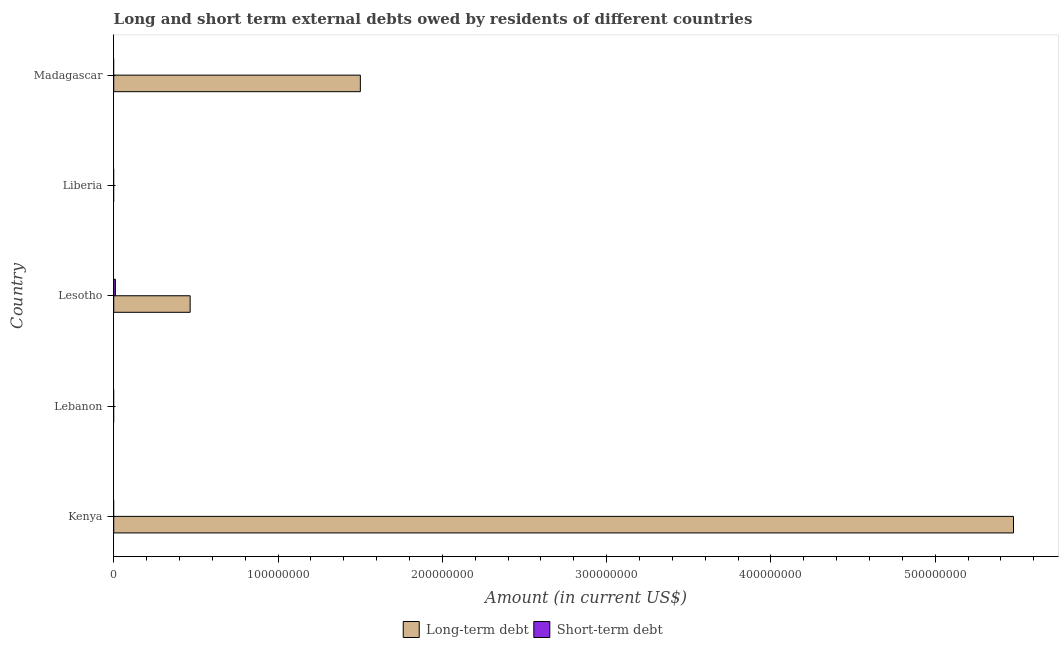How many different coloured bars are there?
Your answer should be compact. 2. Are the number of bars per tick equal to the number of legend labels?
Keep it short and to the point. No. What is the label of the 4th group of bars from the top?
Your answer should be compact. Lebanon. In how many cases, is the number of bars for a given country not equal to the number of legend labels?
Make the answer very short. 4. What is the long-term debts owed by residents in Liberia?
Ensure brevity in your answer.  0. Across all countries, what is the maximum long-term debts owed by residents?
Provide a succinct answer. 5.48e+08. Across all countries, what is the minimum short-term debts owed by residents?
Your response must be concise. 0. In which country was the long-term debts owed by residents maximum?
Provide a succinct answer. Kenya. What is the total long-term debts owed by residents in the graph?
Provide a short and direct response. 7.44e+08. What is the difference between the long-term debts owed by residents in Kenya and that in Lesotho?
Provide a short and direct response. 5.01e+08. What is the difference between the short-term debts owed by residents in Kenya and the long-term debts owed by residents in Madagascar?
Offer a very short reply. -1.50e+08. What is the average short-term debts owed by residents per country?
Your response must be concise. 2.00e+05. What is the difference between the short-term debts owed by residents and long-term debts owed by residents in Lesotho?
Your answer should be compact. -4.55e+07. In how many countries, is the short-term debts owed by residents greater than 280000000 US$?
Provide a short and direct response. 0. What is the difference between the highest and the second highest long-term debts owed by residents?
Ensure brevity in your answer.  3.98e+08. What is the difference between the highest and the lowest long-term debts owed by residents?
Offer a terse response. 5.48e+08. What is the difference between two consecutive major ticks on the X-axis?
Make the answer very short. 1.00e+08. Are the values on the major ticks of X-axis written in scientific E-notation?
Provide a short and direct response. No. Where does the legend appear in the graph?
Make the answer very short. Bottom center. How many legend labels are there?
Provide a short and direct response. 2. How are the legend labels stacked?
Keep it short and to the point. Horizontal. What is the title of the graph?
Give a very brief answer. Long and short term external debts owed by residents of different countries. Does "Males" appear as one of the legend labels in the graph?
Your answer should be compact. No. What is the label or title of the X-axis?
Ensure brevity in your answer.  Amount (in current US$). What is the Amount (in current US$) of Long-term debt in Kenya?
Keep it short and to the point. 5.48e+08. What is the Amount (in current US$) of Long-term debt in Lebanon?
Make the answer very short. 0. What is the Amount (in current US$) of Long-term debt in Lesotho?
Your answer should be very brief. 4.65e+07. What is the Amount (in current US$) of Short-term debt in Lesotho?
Your answer should be very brief. 1.00e+06. What is the Amount (in current US$) in Long-term debt in Liberia?
Offer a terse response. 0. What is the Amount (in current US$) of Short-term debt in Liberia?
Keep it short and to the point. 0. What is the Amount (in current US$) of Long-term debt in Madagascar?
Offer a very short reply. 1.50e+08. Across all countries, what is the maximum Amount (in current US$) of Long-term debt?
Your answer should be very brief. 5.48e+08. Across all countries, what is the minimum Amount (in current US$) of Short-term debt?
Provide a short and direct response. 0. What is the total Amount (in current US$) in Long-term debt in the graph?
Your response must be concise. 7.44e+08. What is the total Amount (in current US$) in Short-term debt in the graph?
Give a very brief answer. 1.00e+06. What is the difference between the Amount (in current US$) of Long-term debt in Kenya and that in Lesotho?
Your answer should be compact. 5.01e+08. What is the difference between the Amount (in current US$) of Long-term debt in Kenya and that in Madagascar?
Keep it short and to the point. 3.98e+08. What is the difference between the Amount (in current US$) in Long-term debt in Lesotho and that in Madagascar?
Ensure brevity in your answer.  -1.04e+08. What is the difference between the Amount (in current US$) in Long-term debt in Kenya and the Amount (in current US$) in Short-term debt in Lesotho?
Provide a succinct answer. 5.47e+08. What is the average Amount (in current US$) in Long-term debt per country?
Your answer should be compact. 1.49e+08. What is the difference between the Amount (in current US$) of Long-term debt and Amount (in current US$) of Short-term debt in Lesotho?
Provide a short and direct response. 4.55e+07. What is the ratio of the Amount (in current US$) in Long-term debt in Kenya to that in Lesotho?
Your answer should be very brief. 11.78. What is the ratio of the Amount (in current US$) in Long-term debt in Kenya to that in Madagascar?
Your answer should be very brief. 3.65. What is the ratio of the Amount (in current US$) of Long-term debt in Lesotho to that in Madagascar?
Offer a very short reply. 0.31. What is the difference between the highest and the second highest Amount (in current US$) in Long-term debt?
Ensure brevity in your answer.  3.98e+08. What is the difference between the highest and the lowest Amount (in current US$) of Long-term debt?
Ensure brevity in your answer.  5.48e+08. What is the difference between the highest and the lowest Amount (in current US$) of Short-term debt?
Offer a terse response. 1.00e+06. 